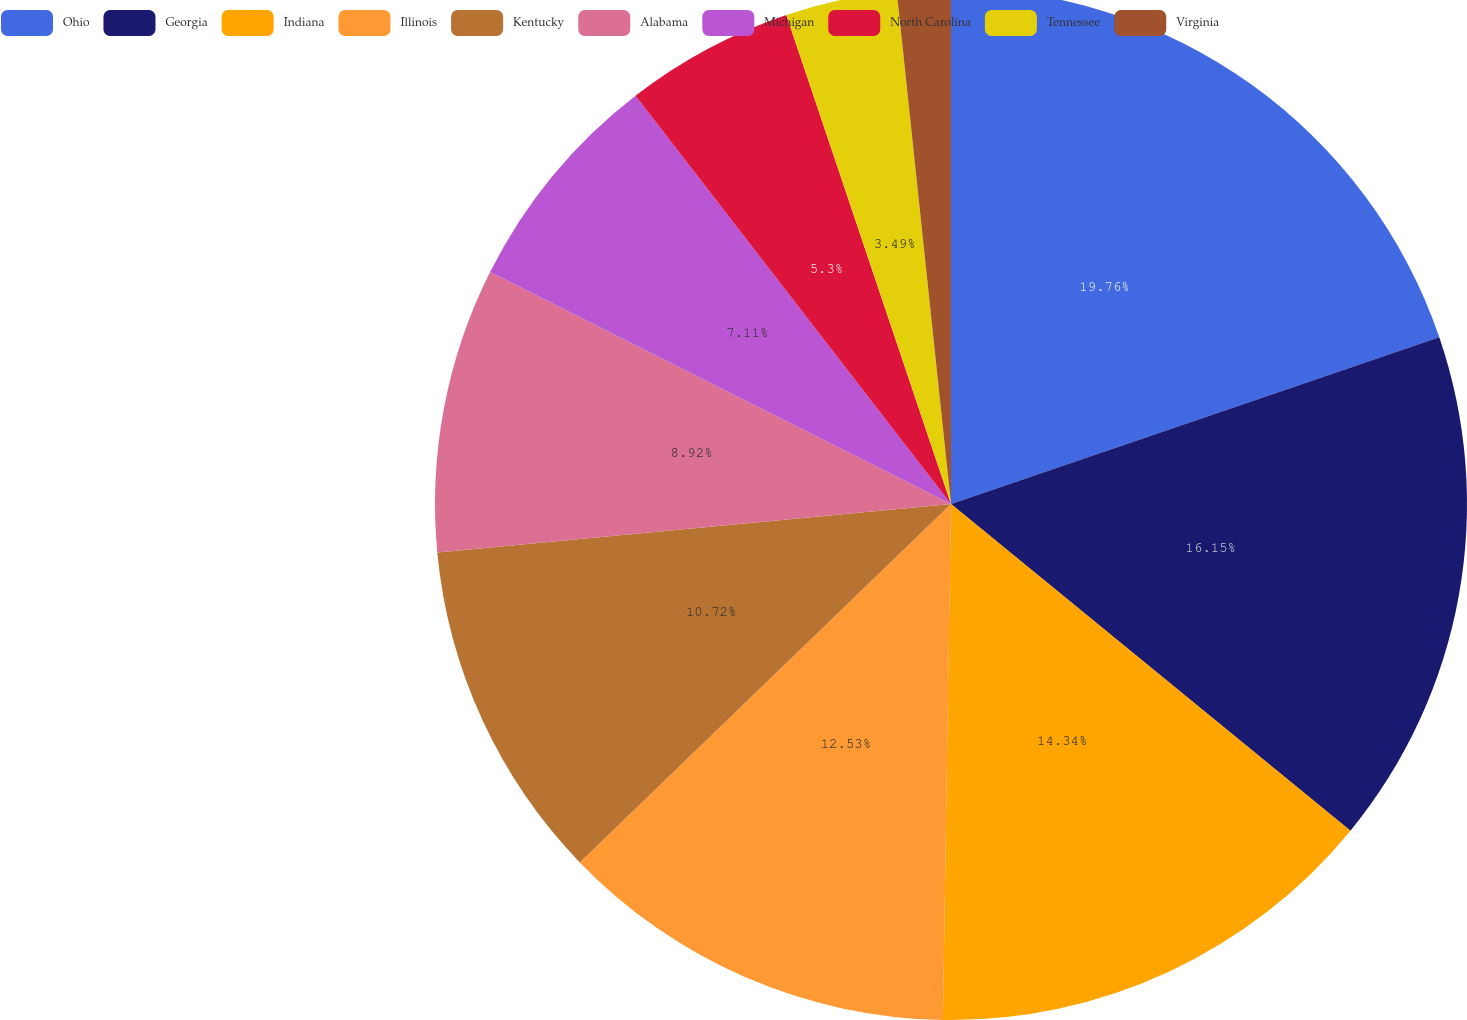<chart> <loc_0><loc_0><loc_500><loc_500><pie_chart><fcel>Ohio<fcel>Georgia<fcel>Indiana<fcel>Illinois<fcel>Kentucky<fcel>Alabama<fcel>Michigan<fcel>North Carolina<fcel>Tennessee<fcel>Virginia<nl><fcel>19.76%<fcel>16.15%<fcel>14.34%<fcel>12.53%<fcel>10.72%<fcel>8.92%<fcel>7.11%<fcel>5.3%<fcel>3.49%<fcel>1.68%<nl></chart> 